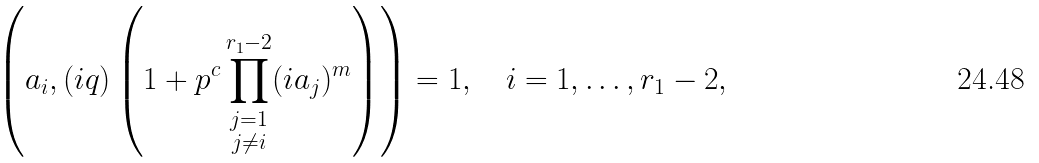<formula> <loc_0><loc_0><loc_500><loc_500>\left ( a _ { i } , ( i q ) \left ( 1 + p ^ { c } \prod _ { \substack { j = 1 \\ j \neq i } } ^ { r _ { 1 } - 2 } ( i a _ { j } ) ^ { m } \right ) \right ) = 1 , \quad i = 1 , \dots , r _ { 1 } - 2 ,</formula> 